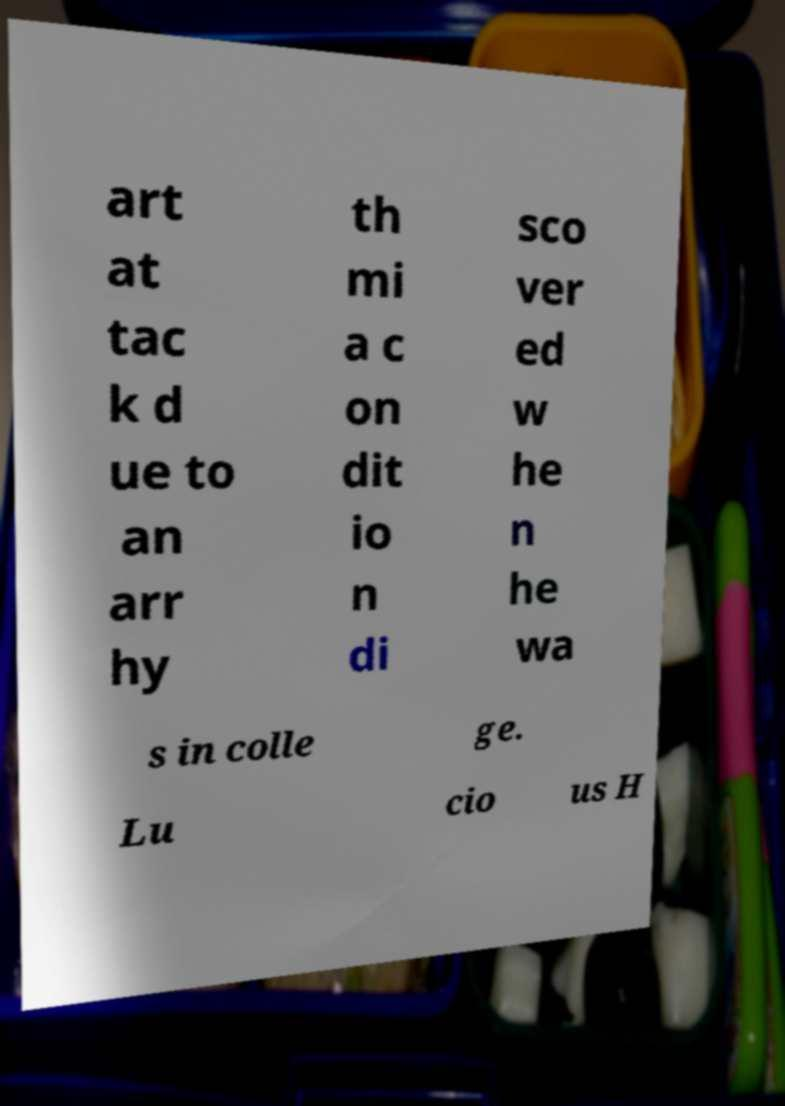What messages or text are displayed in this image? I need them in a readable, typed format. art at tac k d ue to an arr hy th mi a c on dit io n di sco ver ed w he n he wa s in colle ge. Lu cio us H 